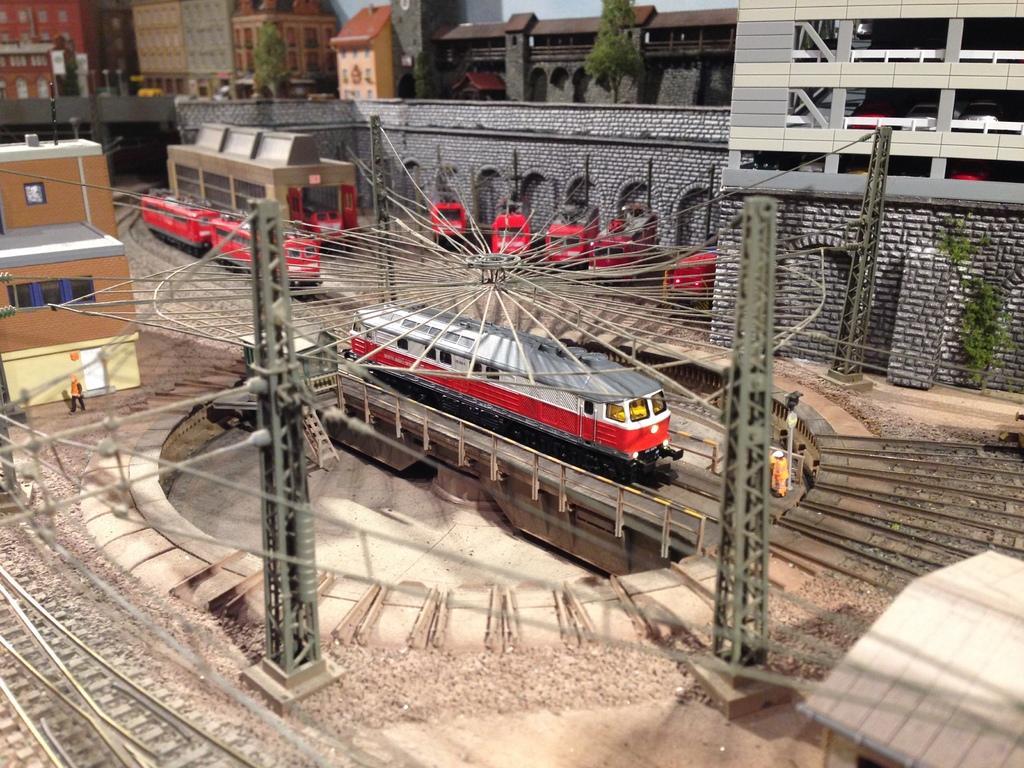Describe this image in one or two sentences. We can see trains on tracks and we can see buildings,trees,house,wall,towers and sky. 